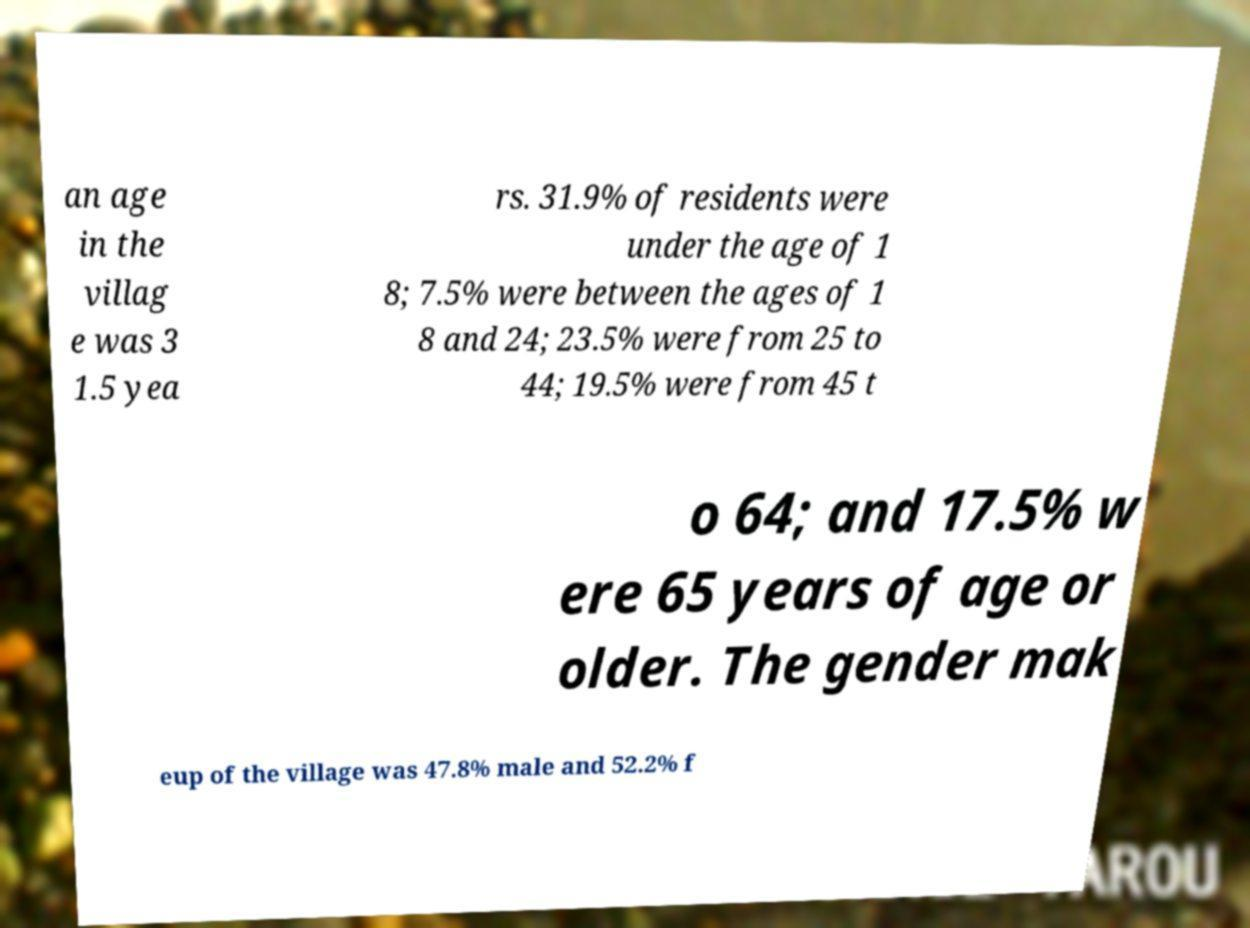Please read and relay the text visible in this image. What does it say? an age in the villag e was 3 1.5 yea rs. 31.9% of residents were under the age of 1 8; 7.5% were between the ages of 1 8 and 24; 23.5% were from 25 to 44; 19.5% were from 45 t o 64; and 17.5% w ere 65 years of age or older. The gender mak eup of the village was 47.8% male and 52.2% f 